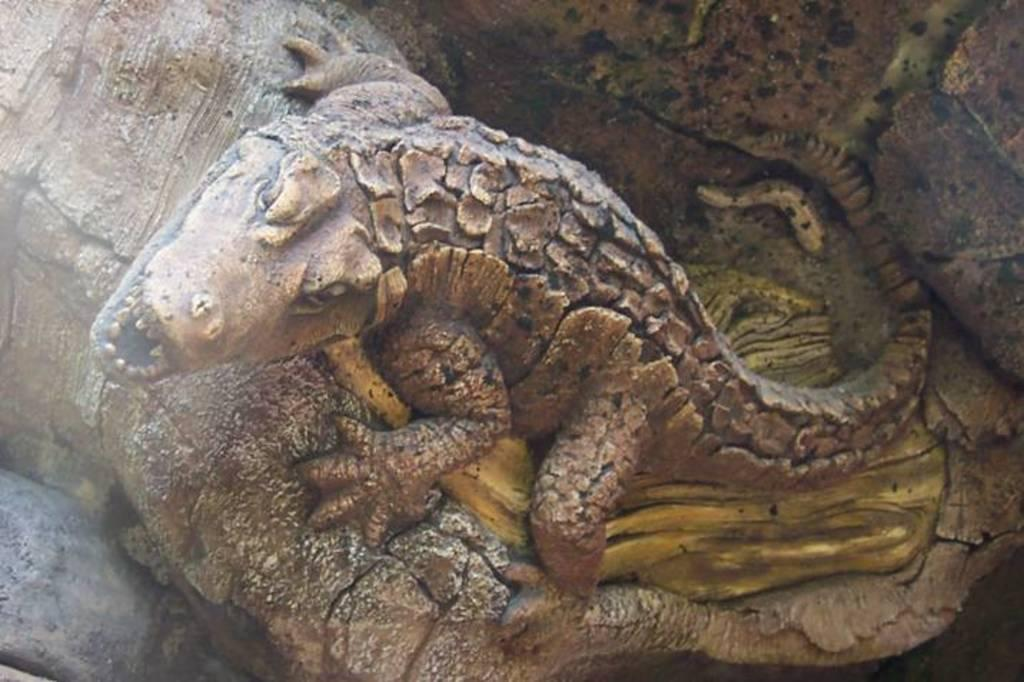What type of animal is carved into the tree trunk in the image? There is a reptile carved into the trunk of a tree in the image. What other living creature can be seen in the image? There is an insect visible in the image. What non-living object is present in the image? There is a rock in the image. What type of alarm can be heard in the image? There is no alarm present in the image, as it is a static representation of a carved reptile, an insect, and a rock. 